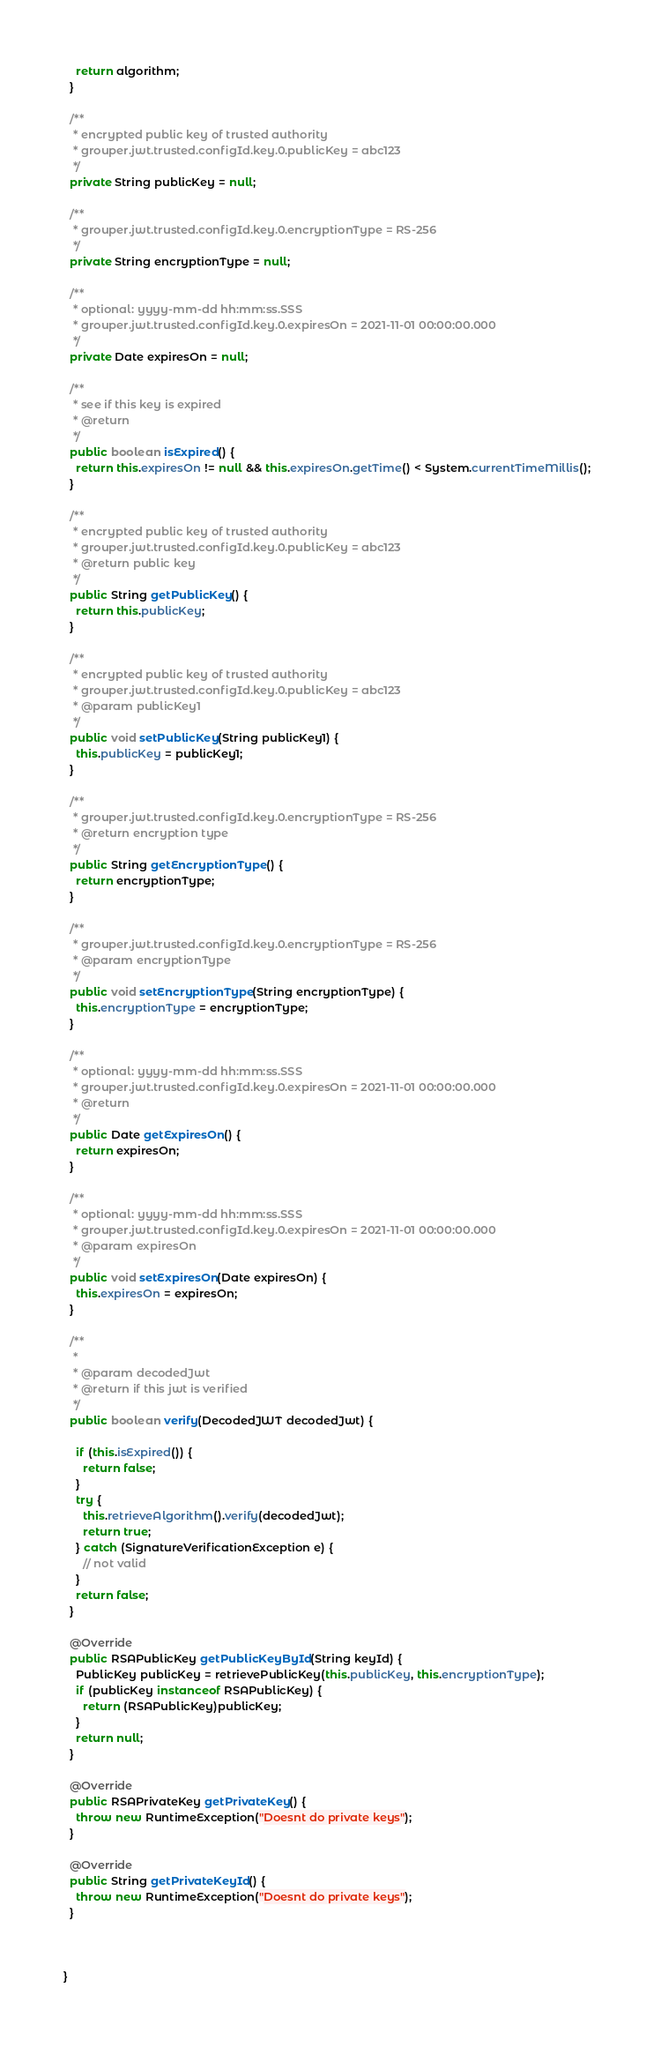Convert code to text. <code><loc_0><loc_0><loc_500><loc_500><_Java_>    return algorithm;
  }
  
  /**
   * encrypted public key of trusted authority
   * grouper.jwt.trusted.configId.key.0.publicKey = abc123
   */
  private String publicKey = null;
  
  /**
   * grouper.jwt.trusted.configId.key.0.encryptionType = RS-256
   */
  private String encryptionType = null;

  /**
   * optional: yyyy-mm-dd hh:mm:ss.SSS
   * grouper.jwt.trusted.configId.key.0.expiresOn = 2021-11-01 00:00:00.000
   */
  private Date expiresOn = null;

  /**
   * see if this key is expired
   * @return
   */
  public boolean isExpired() {
    return this.expiresOn != null && this.expiresOn.getTime() < System.currentTimeMillis();
  }
  
  /**
   * encrypted public key of trusted authority
   * grouper.jwt.trusted.configId.key.0.publicKey = abc123
   * @return public key
   */
  public String getPublicKey() {
    return this.publicKey;
  }

  /**
   * encrypted public key of trusted authority
   * grouper.jwt.trusted.configId.key.0.publicKey = abc123
   * @param publicKey1
   */
  public void setPublicKey(String publicKey1) {
    this.publicKey = publicKey1;
  }

  /**
   * grouper.jwt.trusted.configId.key.0.encryptionType = RS-256
   * @return encryption type
   */
  public String getEncryptionType() {
    return encryptionType;
  }

  /**
   * grouper.jwt.trusted.configId.key.0.encryptionType = RS-256
   * @param encryptionType
   */
  public void setEncryptionType(String encryptionType) {
    this.encryptionType = encryptionType;
  }

  /**
   * optional: yyyy-mm-dd hh:mm:ss.SSS
   * grouper.jwt.trusted.configId.key.0.expiresOn = 2021-11-01 00:00:00.000
   * @return
   */
  public Date getExpiresOn() {
    return expiresOn;
  }

  /**
   * optional: yyyy-mm-dd hh:mm:ss.SSS
   * grouper.jwt.trusted.configId.key.0.expiresOn = 2021-11-01 00:00:00.000
   * @param expiresOn
   */
  public void setExpiresOn(Date expiresOn) {
    this.expiresOn = expiresOn;
  }

  /**
   * 
   * @param decodedJwt
   * @return if this jwt is verified
   */
  public boolean verify(DecodedJWT decodedJwt) {
    
    if (this.isExpired()) {
      return false;
    }
    try {
      this.retrieveAlgorithm().verify(decodedJwt);
      return true;
    } catch (SignatureVerificationException e) {
      // not valid
    }
    return false;
  }

  @Override
  public RSAPublicKey getPublicKeyById(String keyId) {
    PublicKey publicKey = retrievePublicKey(this.publicKey, this.encryptionType);
    if (publicKey instanceof RSAPublicKey) {
      return (RSAPublicKey)publicKey;
    }
    return null;
  }

  @Override
  public RSAPrivateKey getPrivateKey() {
    throw new RuntimeException("Doesnt do private keys");
  }

  @Override
  public String getPrivateKeyId() {
    throw new RuntimeException("Doesnt do private keys");
  }
  
  
  
}
</code> 